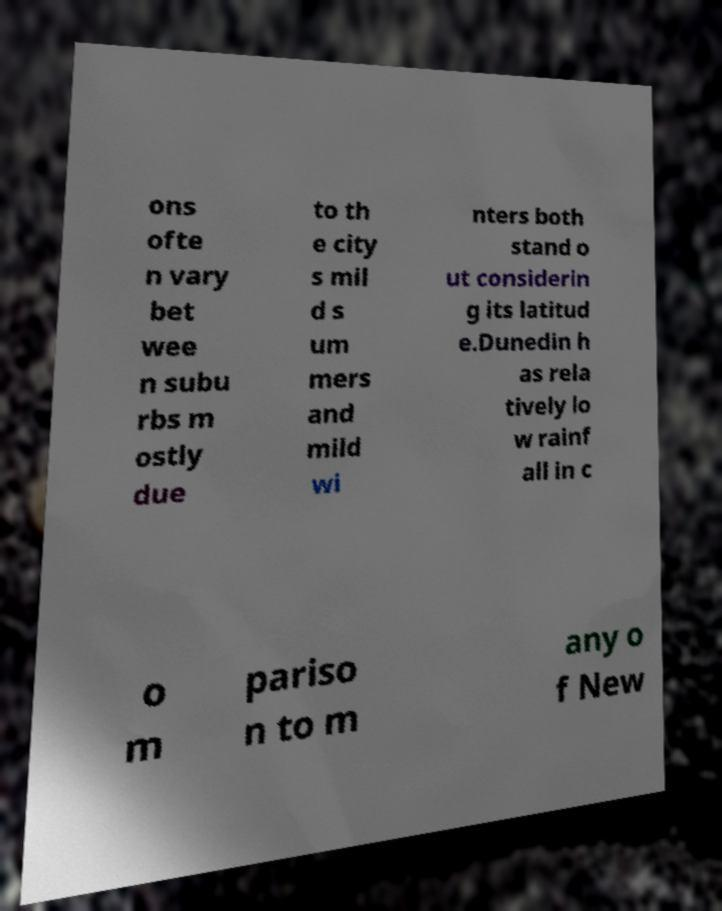Could you extract and type out the text from this image? ons ofte n vary bet wee n subu rbs m ostly due to th e city s mil d s um mers and mild wi nters both stand o ut considerin g its latitud e.Dunedin h as rela tively lo w rainf all in c o m pariso n to m any o f New 